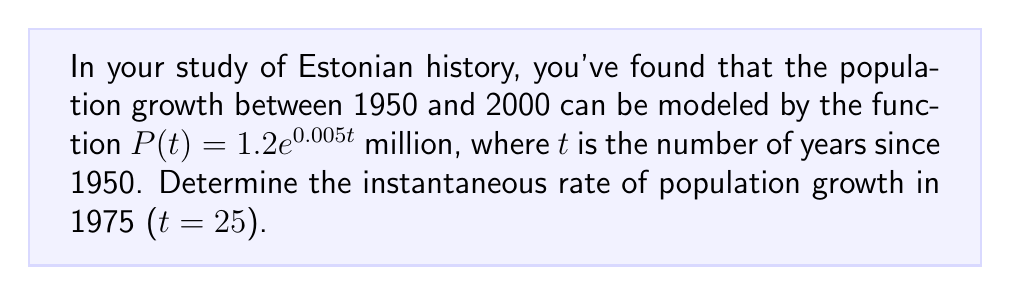Give your solution to this math problem. To find the instantaneous rate of population growth in 1975, we need to calculate the derivative of the population function $P(t)$ and evaluate it at $t = 25$.

Step 1: Find the derivative of $P(t)$
$$P(t) = 1.2e^{0.005t}$$
$$P'(t) = 1.2 \cdot 0.005 \cdot e^{0.005t} = 0.006e^{0.005t}$$

Step 2: Evaluate $P'(t)$ at $t = 25$
$$P'(25) = 0.006e^{0.005 \cdot 25} = 0.006e^{0.125}$$

Step 3: Calculate the final value
$$P'(25) = 0.006 \cdot 1.133148 \approx 0.006799$$

The instantaneous rate of population growth in 1975 is approximately 0.006799 million people per year, or about 6,799 people per year.
Answer: $0.006799$ million/year 